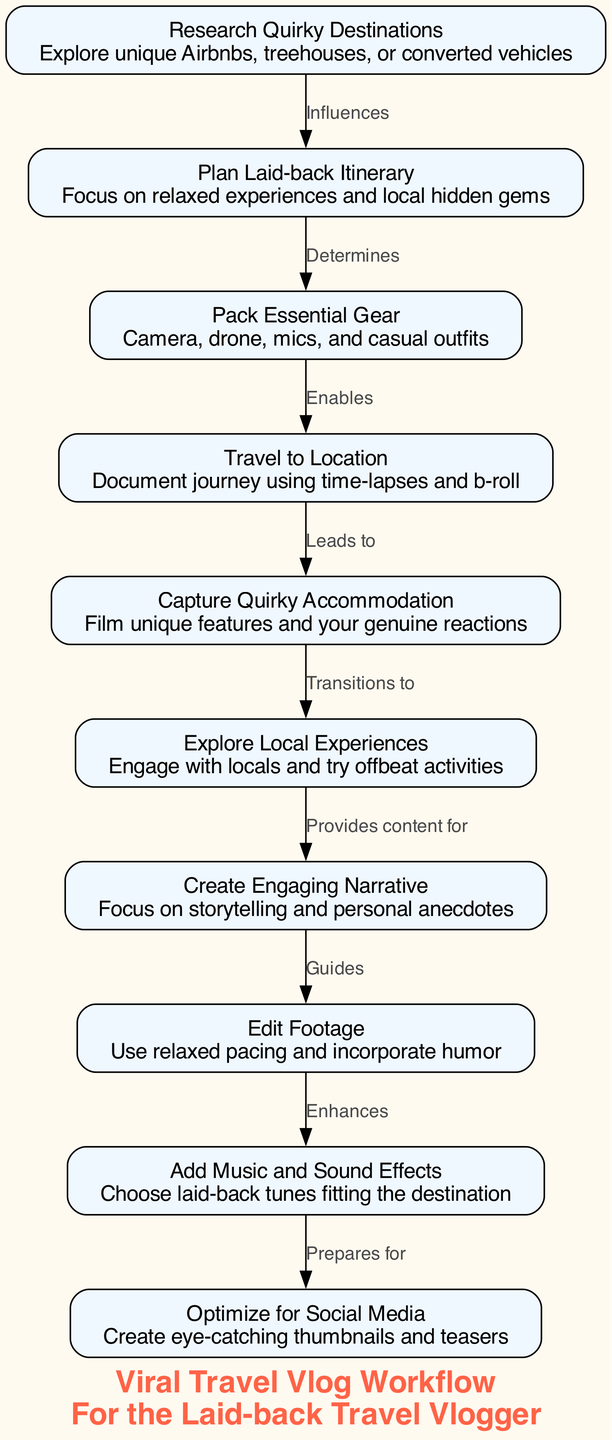What is the first step in the workflow? The workflow starts with the node labeled "Research Quirky Destinations", which is the first node depicted in the flow.
Answer: Research Quirky Destinations How many nodes are in the diagram? By counting the distinct nodes shown in the diagram, there are ten nodes represented in total.
Answer: 10 What type of relationship exists between "Capture Quirky Accommodation" and "Explore Local Experiences"? The flow indicates a "Transitions to" relationship, which connects the capture of accommodation to the exploration of local experiences.
Answer: Transitions to What does the step "Edit Footage" lead to? The "Edit Footage" step in the diagram is followed by the "Add Music and Sound Effects," indicating that it directly leads to this next process.
Answer: Add Music and Sound Effects What influences the "Plan Laid-back Itinerary"? According to the diagram, the "Research Quirky Destinations" step influences the planning of a laid-back itinerary.
Answer: Research Quirky Destinations Which node provides content for "Create Engaging Narrative"? The "Explore Local Experiences" node provides the necessary content required to create an engaging narrative in the travel vlog workflow.
Answer: Explore Local Experiences What enhances the editing process? The "Add Music and Sound Effects" step enhances the editing process, as indicated by the directional flow in the diagram from editing to adding audio elements.
Answer: Add Music and Sound Effects What preparation does "Add Music and Sound Effects" facilitate? This step prepares the workflow for "Optimize for Social Media," illustrated by the direct link connecting the two nodes.
Answer: Optimize for Social Media Which step is determined by planning the itinerary? The step that is determined following the planning of the laid-back itinerary is "Pack Essential Gear," which is connected in this manner in the workflow.
Answer: Pack Essential Gear 